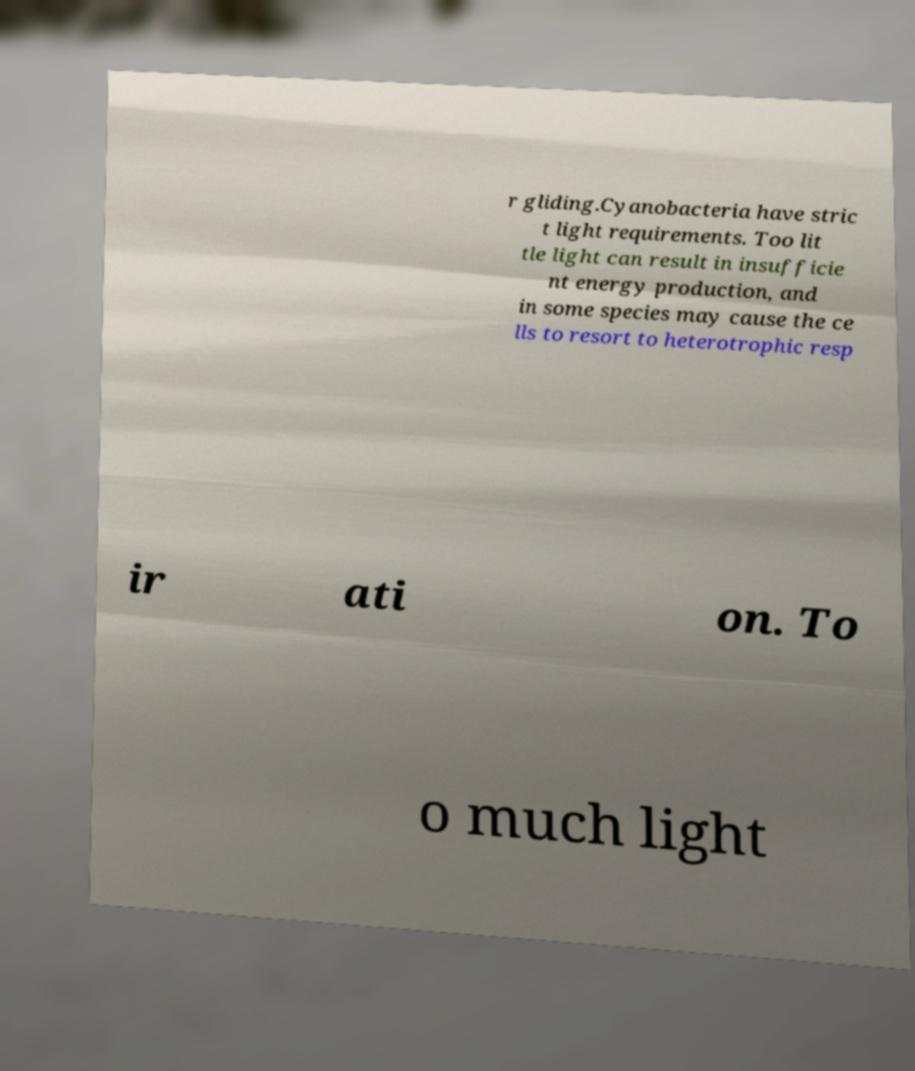For documentation purposes, I need the text within this image transcribed. Could you provide that? r gliding.Cyanobacteria have stric t light requirements. Too lit tle light can result in insufficie nt energy production, and in some species may cause the ce lls to resort to heterotrophic resp ir ati on. To o much light 